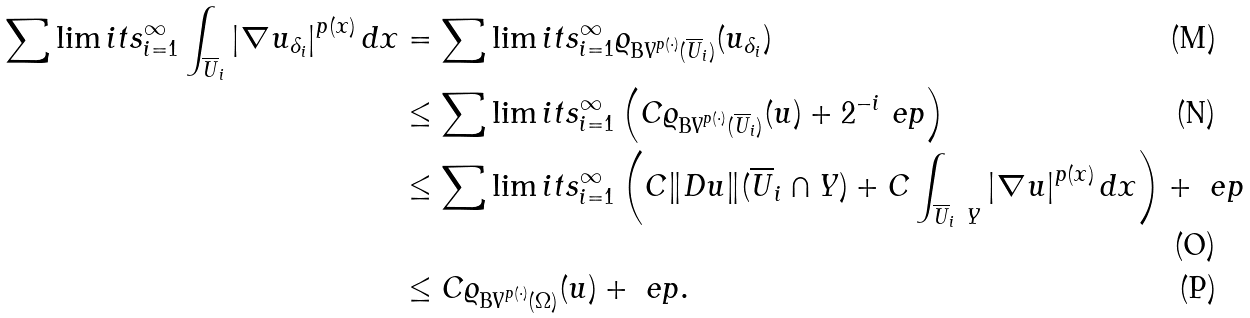<formula> <loc_0><loc_0><loc_500><loc_500>\sum \lim i t s _ { i = 1 } ^ { \infty } \int _ { \overline { U } _ { i } } \left | \nabla u _ { \delta _ { i } } \right | ^ { p ( x ) } d x & = \sum \lim i t s _ { i = 1 } ^ { \infty } \varrho _ { \text {BV} ^ { p ( \cdot ) } ( \overline { U } _ { i } ) } ( u _ { \delta _ { i } } ) \\ & \leq \sum \lim i t s _ { i = 1 } ^ { \infty } \left ( C \varrho _ { \text {BV} ^ { p ( \cdot ) } ( \overline { U } _ { i } ) } ( u ) + 2 ^ { - i } \ e p \right ) \\ & \leq \sum \lim i t s _ { i = 1 } ^ { \infty } \left ( C \| D u \| ( \overline { U } _ { i } \cap Y ) + C \int _ { \overline { U } _ { i } \ Y } \left | \nabla u \right | ^ { p ( x ) } d x \right ) + \ e p \\ & \leq C \varrho _ { \text {BV} ^ { p ( \cdot ) } ( \Omega ) } ( u ) + \ e p .</formula> 